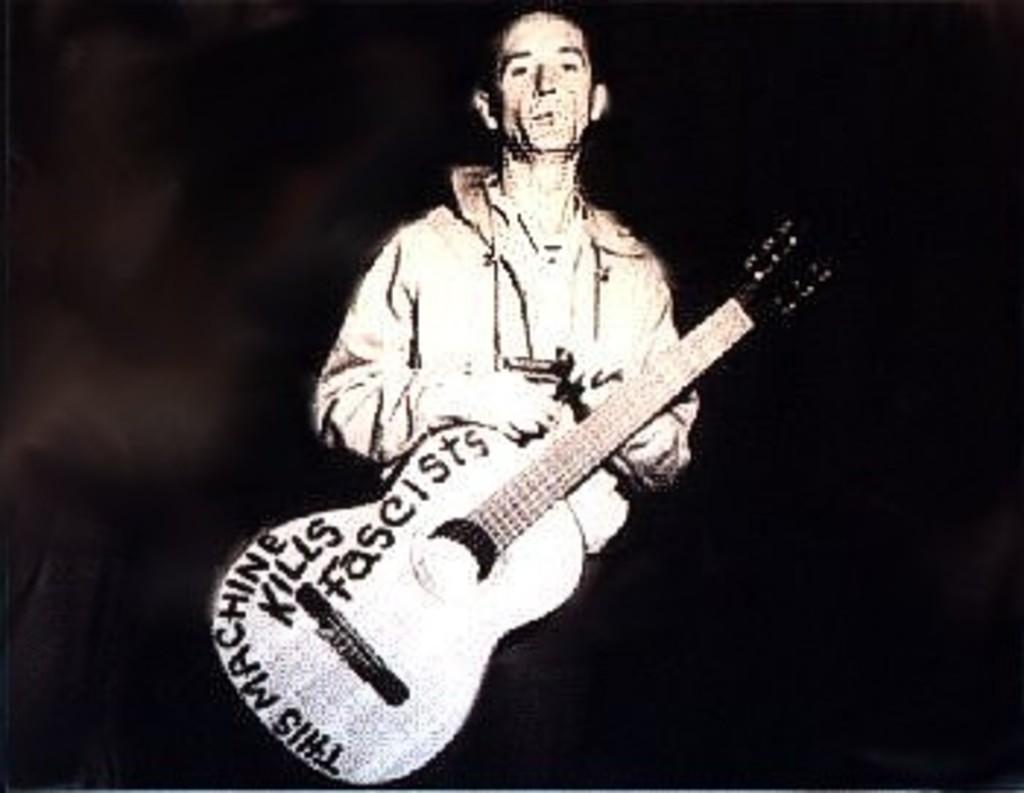What is the color scheme of the image? The image is black and white. Who is present in the image? There is a man in the image. What is the man holding in the image? The man is holding a guitar. What can be seen behind the man in the image? The background of the man is black. What type of business is the man promoting in the image? There is no indication of a business in the image; it simply features a man holding a guitar. What type of root can be seen growing from the guitar in the image? There are no roots visible in the image, and the guitar is not a plant. 